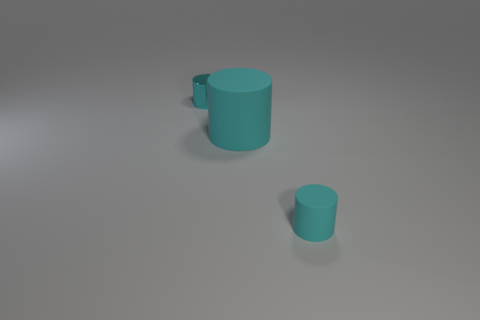Add 2 small cyan objects. How many objects exist? 5 Subtract all small cylinders. How many cylinders are left? 1 Add 3 tiny cyan metallic cylinders. How many tiny cyan metallic cylinders are left? 4 Add 3 cyan metal cylinders. How many cyan metal cylinders exist? 4 Subtract 0 red cylinders. How many objects are left? 3 Subtract all purple cylinders. Subtract all yellow blocks. How many cylinders are left? 3 Subtract all small rubber cylinders. Subtract all tiny cyan matte cylinders. How many objects are left? 1 